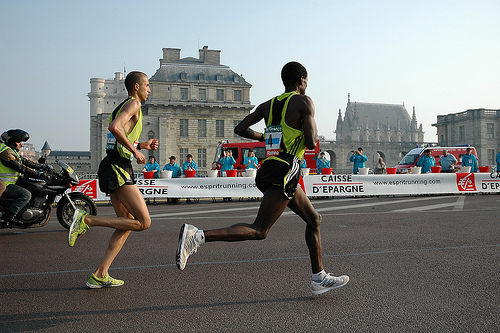Are the ground texture details rich in the image? The image presents a moderately detailed ground texture, which appears to be smooth asphalt with painted lines indicating the boundaries of a running course. There are some variations in surface color and markings, providing a sense of depth and usage, but the texture may not be described as 'rich' due to limited complexity and variety. 